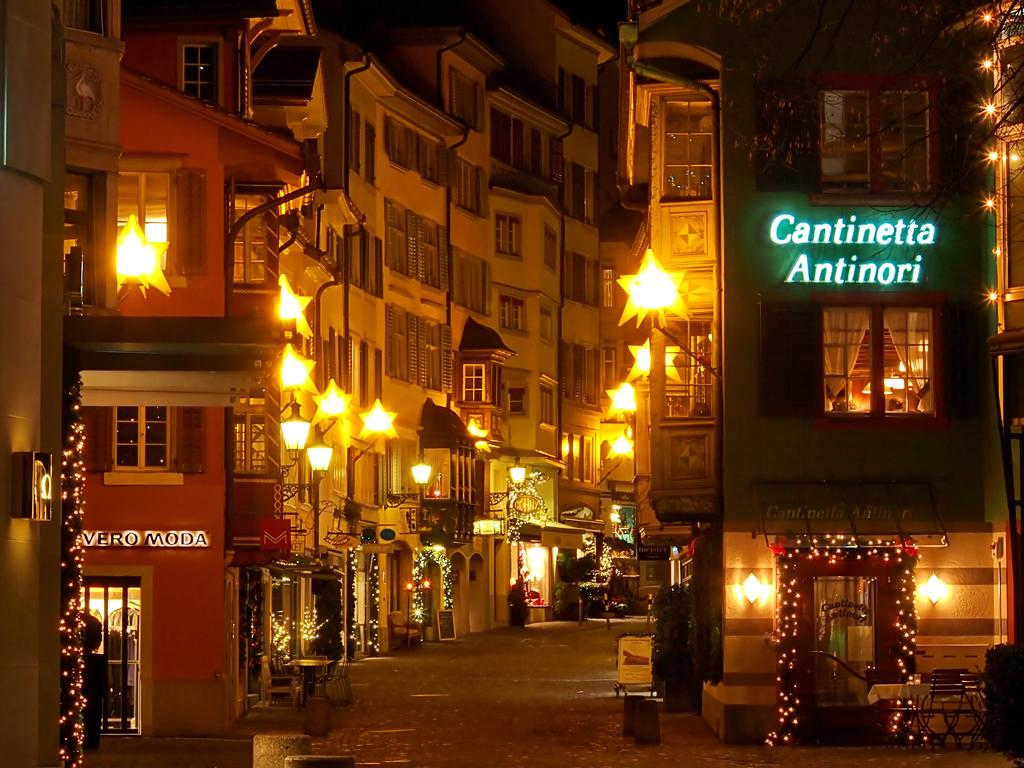What is in the foreground of the image? There is a pavement in the foreground of the image. What can be seen in the background of the image? There are buildings and stars visible in the background of the image. What type of lighting is present in the background of the image? Decorated lights are present in the background of the image. What is the tax rate for the homes in the image? There is no information about tax rates or homes in the image; it only shows a pavement, buildings, stars, and decorated lights. What type of recess can be seen in the image? There is no recess present in the image. 